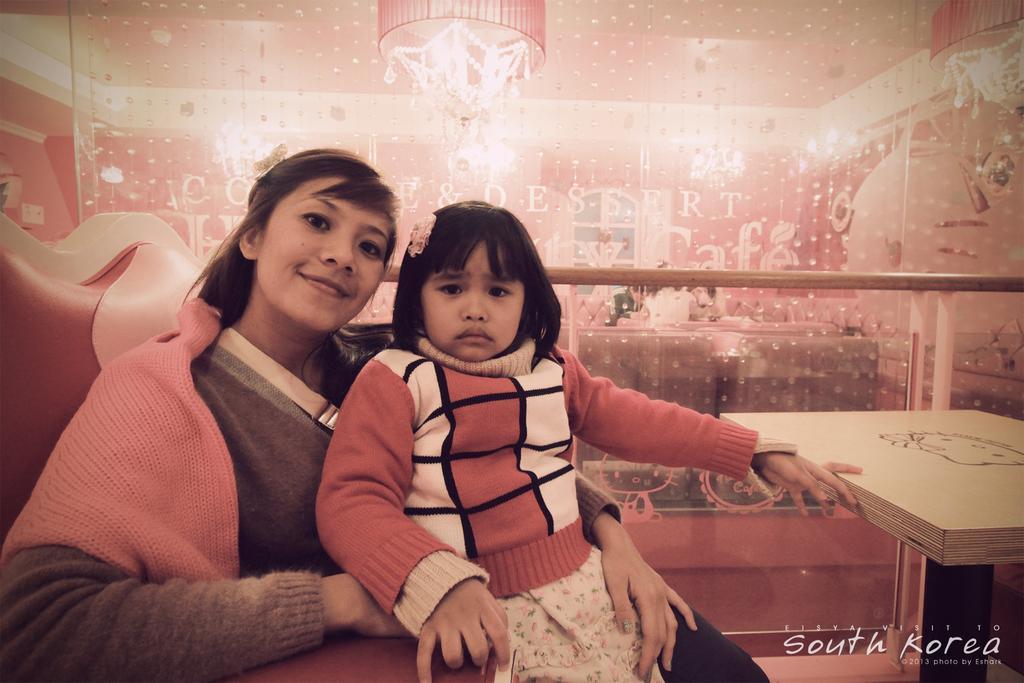Describe this image in one or two sentences. In this image there is a woman who is sitting in the sofa by holding the kid. Beside them there is a table. Behind them there is a fence. At the top there is a chandelier. In the background there is a design. 